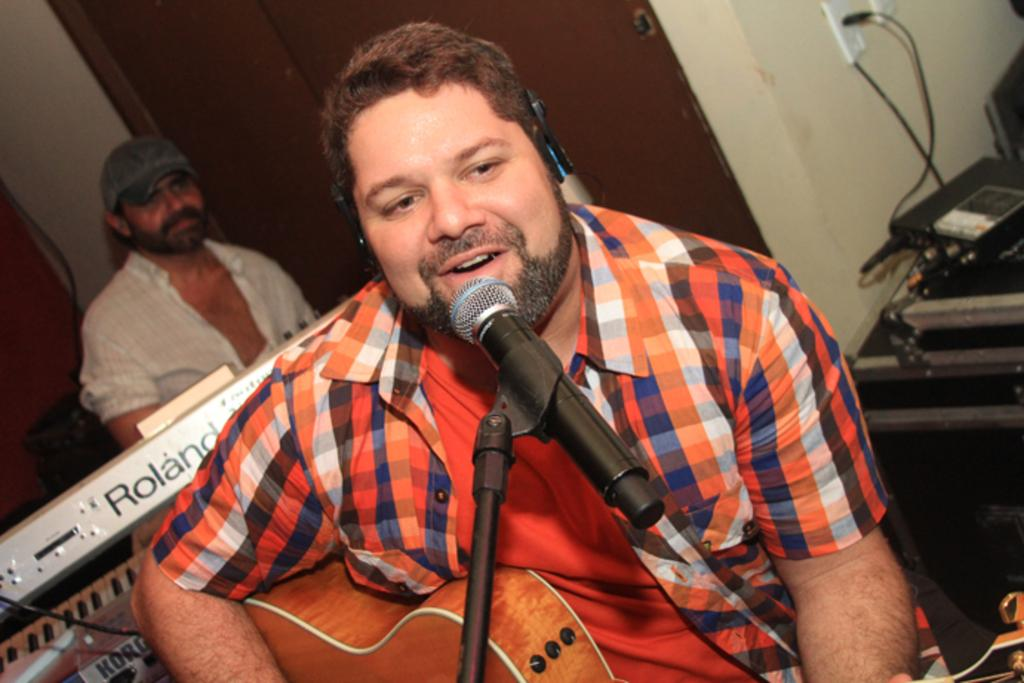What is the main subject of the image? The main subject of the image is a guy. What is the guy wearing? The guy is wearing an orange shirt. What is the guy holding in the image? The guy is holding a guitar. What is the guy doing with the guitar? The guy is playing the guitar. What other object can be seen in the image? There is a microphone in the image. Can you describe the background of the image? There is another guy in the background of the image, and there are musical instruments present. What type of card is the guy using to play the guitar in the image? There is no card present in the image, and the guy is playing the guitar using his hands, not a card. 